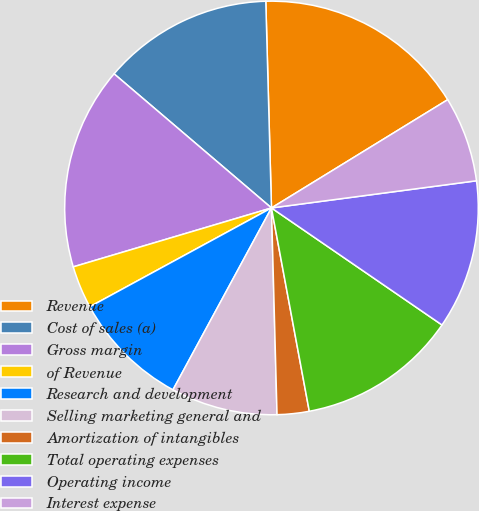<chart> <loc_0><loc_0><loc_500><loc_500><pie_chart><fcel>Revenue<fcel>Cost of sales (a)<fcel>Gross margin<fcel>of Revenue<fcel>Research and development<fcel>Selling marketing general and<fcel>Amortization of intangibles<fcel>Total operating expenses<fcel>Operating income<fcel>Interest expense<nl><fcel>16.67%<fcel>13.33%<fcel>15.83%<fcel>3.33%<fcel>9.17%<fcel>8.33%<fcel>2.5%<fcel>12.5%<fcel>11.67%<fcel>6.67%<nl></chart> 